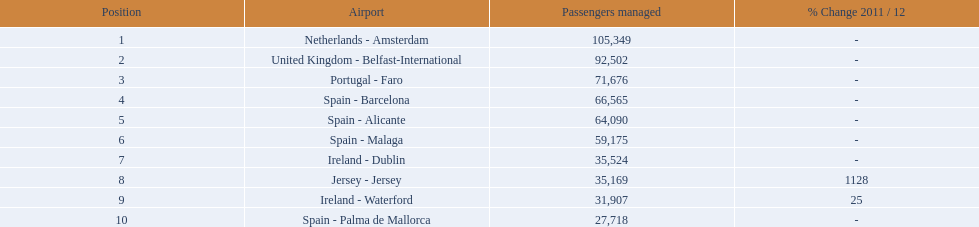What are all of the destinations out of the london southend airport? Netherlands - Amsterdam, United Kingdom - Belfast-International, Portugal - Faro, Spain - Barcelona, Spain - Alicante, Spain - Malaga, Ireland - Dublin, Jersey - Jersey, Ireland - Waterford, Spain - Palma de Mallorca. How many passengers has each destination handled? 105,349, 92,502, 71,676, 66,565, 64,090, 59,175, 35,524, 35,169, 31,907, 27,718. And of those, which airport handled the fewest passengers? Spain - Palma de Mallorca. 